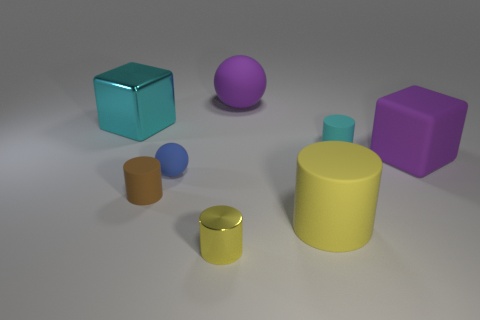What can you tell me about the different colors of the objects? The image showcases a variety of colors with objects ranging from blue, purple, and pink, to brown, yellow, and a shade of violet. This selection offers a visually diverse palette that could be used to discuss color theory or contrasting and complementing colors in design.  Do the objects have different textures or are they all the same? Based on the image, all objects seem to have a relatively smooth and similar matte finish, suggesting no apparent texture differences. While it's possible that the actual material properties could vary, the visual cues do not indicate significant textural variation. 